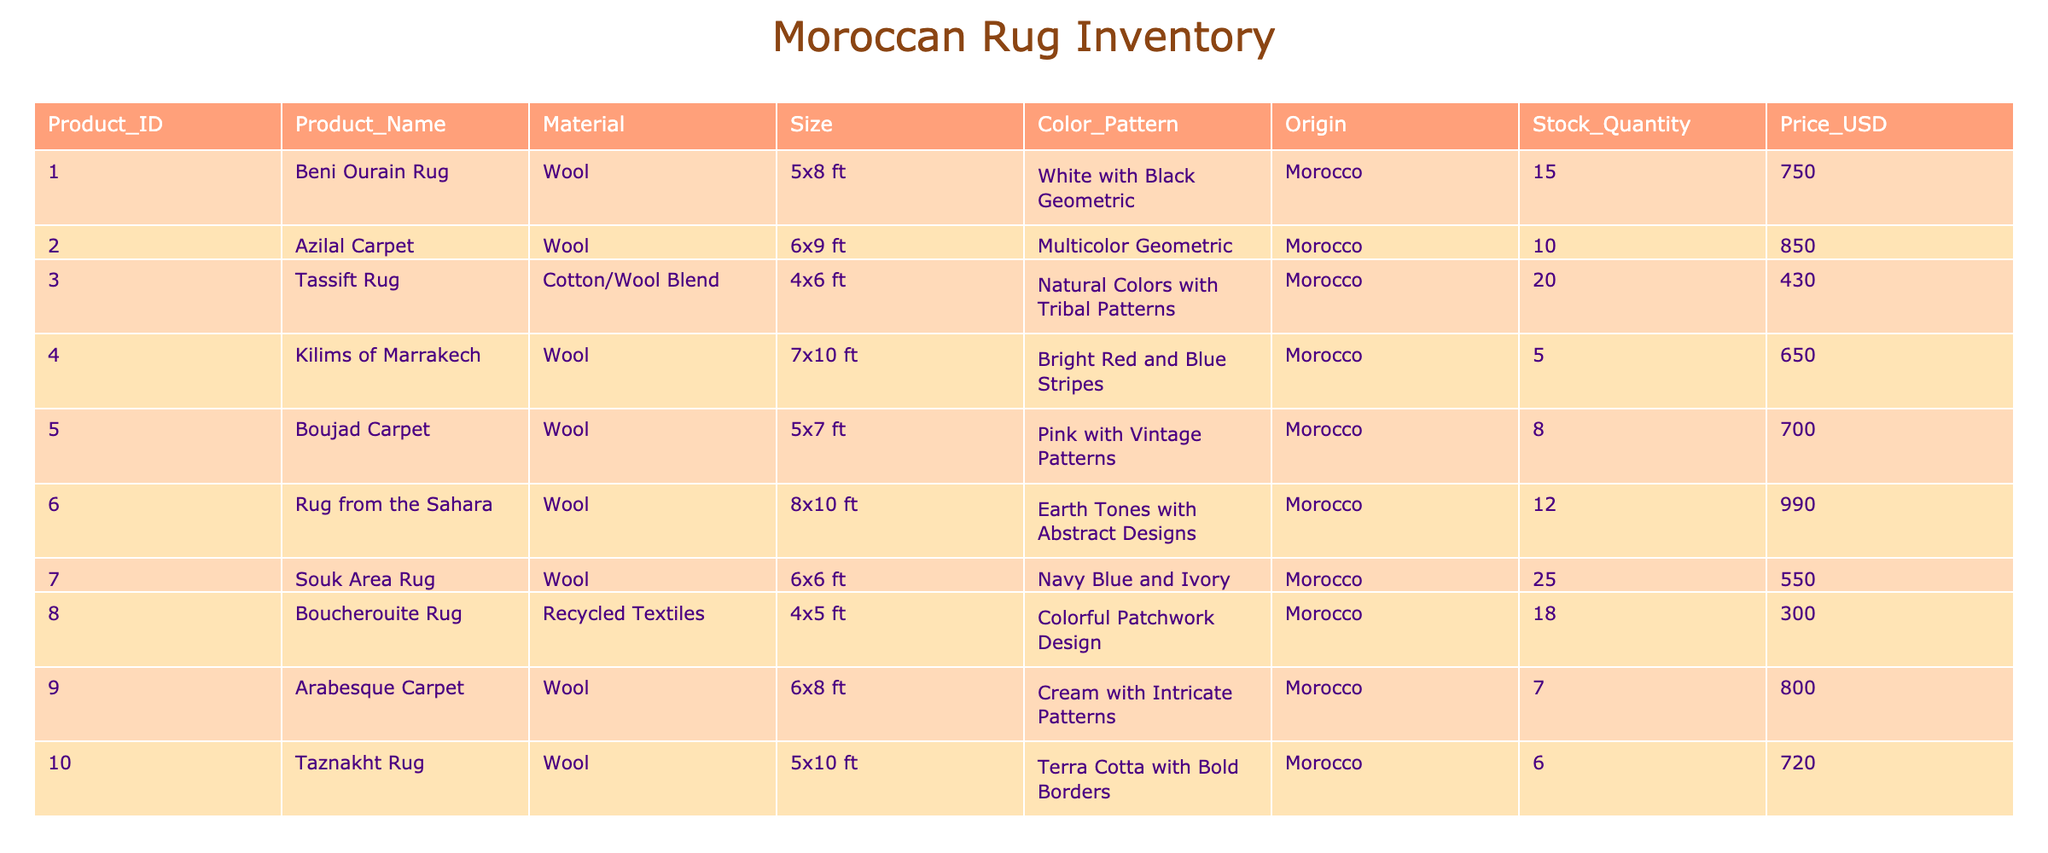What is the most expensive rug in the inventory? The highest price listed in the table is $990 for the "Rug from the Sahara." By checking the Price_USD column, this is confirmed as the highest value.
Answer: Rug from the Sahara How many total rugs are available in stock? To find the total stock quantity, I add up the Stock_Quantity column: 15 + 10 + 20 + 5 + 8 + 12 + 25 + 18 + 7 + 6 = 126. Therefore, the total stock is 126 rugs available.
Answer: 126 Is there a carpet made from recycled materials? Yes, the "Boucherouite Rug" is listed as made from recycled textiles. This can be verified by looking at the Material column in the table.
Answer: Yes What is the average price of all the Moroccan rugs? To find the average price, first, I sum all the prices: 750 + 850 + 430 + 650 + 700 + 990 + 550 + 300 + 800 + 720 = 6,240. There are 10 rugs, so I divide 6,240 by 10, which equals 624. Therefore, the average price is $624.
Answer: 624 How many rugs have a geometric color pattern? Upon examining the Color_Pattern column, the rugs with geometric patterns are: "White with Black Geometric," "Multicolor Geometric," and "Navy Blue and Ivory." That totals three rugs with geometric patterns.
Answer: 3 